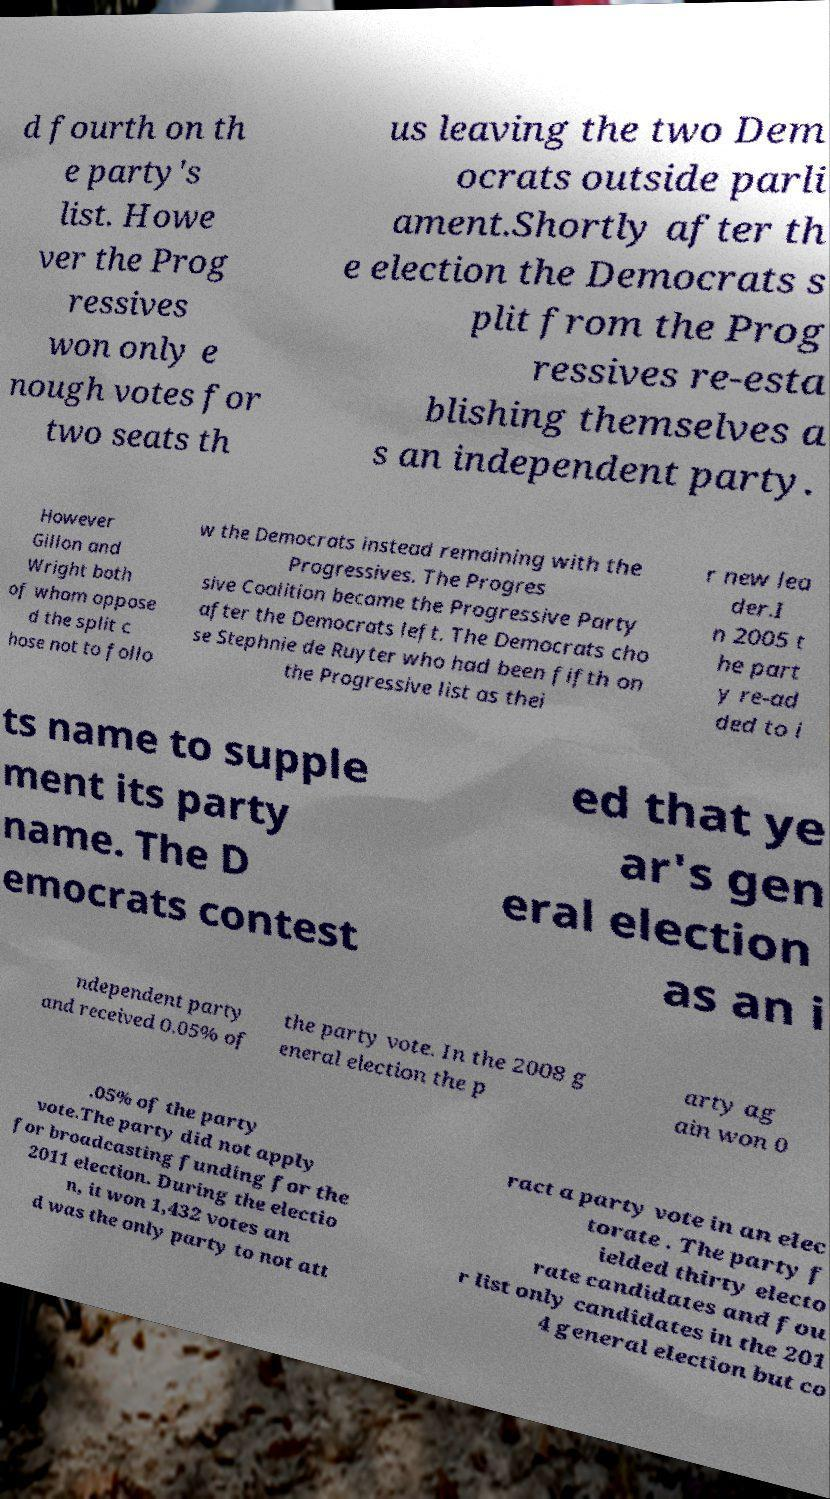There's text embedded in this image that I need extracted. Can you transcribe it verbatim? d fourth on th e party's list. Howe ver the Prog ressives won only e nough votes for two seats th us leaving the two Dem ocrats outside parli ament.Shortly after th e election the Democrats s plit from the Prog ressives re-esta blishing themselves a s an independent party. However Gillon and Wright both of whom oppose d the split c hose not to follo w the Democrats instead remaining with the Progressives. The Progres sive Coalition became the Progressive Party after the Democrats left. The Democrats cho se Stephnie de Ruyter who had been fifth on the Progressive list as thei r new lea der.I n 2005 t he part y re-ad ded to i ts name to supple ment its party name. The D emocrats contest ed that ye ar's gen eral election as an i ndependent party and received 0.05% of the party vote. In the 2008 g eneral election the p arty ag ain won 0 .05% of the party vote.The party did not apply for broadcasting funding for the 2011 election. During the electio n, it won 1,432 votes an d was the only party to not att ract a party vote in an elec torate . The party f ielded thirty electo rate candidates and fou r list only candidates in the 201 4 general election but co 